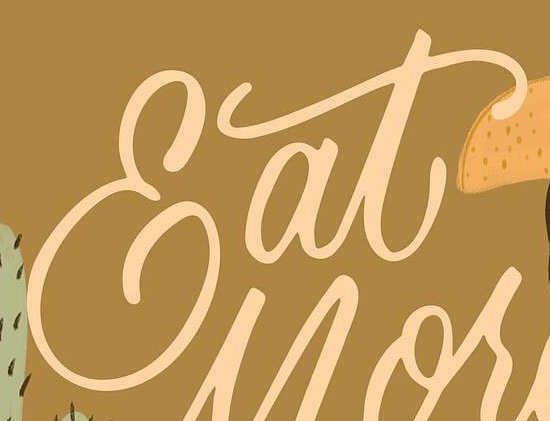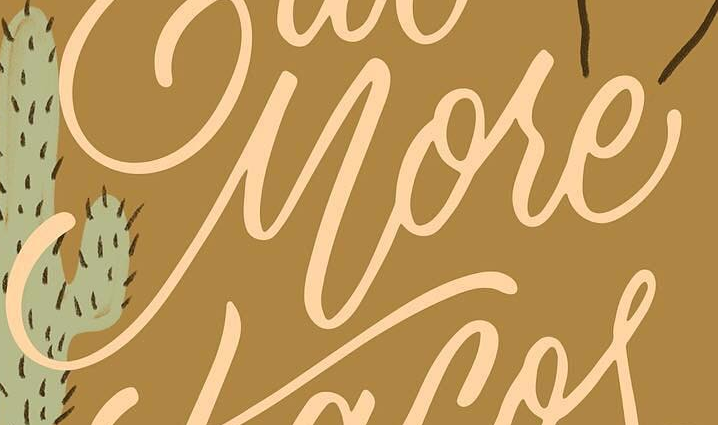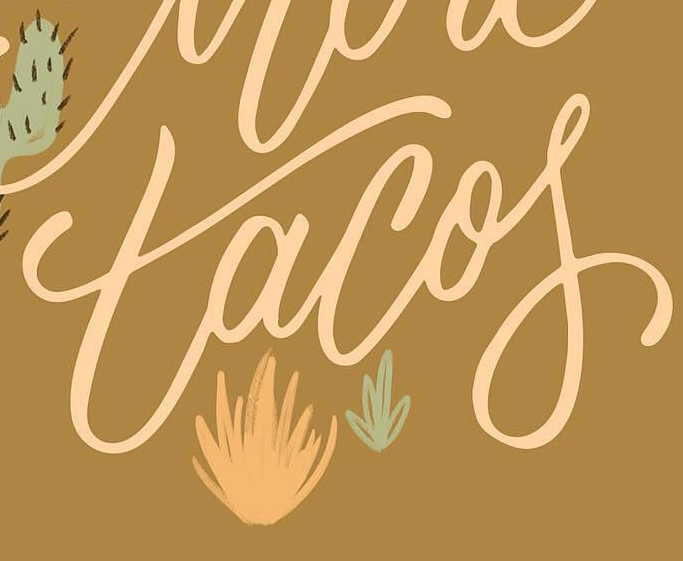Read the text from these images in sequence, separated by a semicolon. Eat; More; tacof 